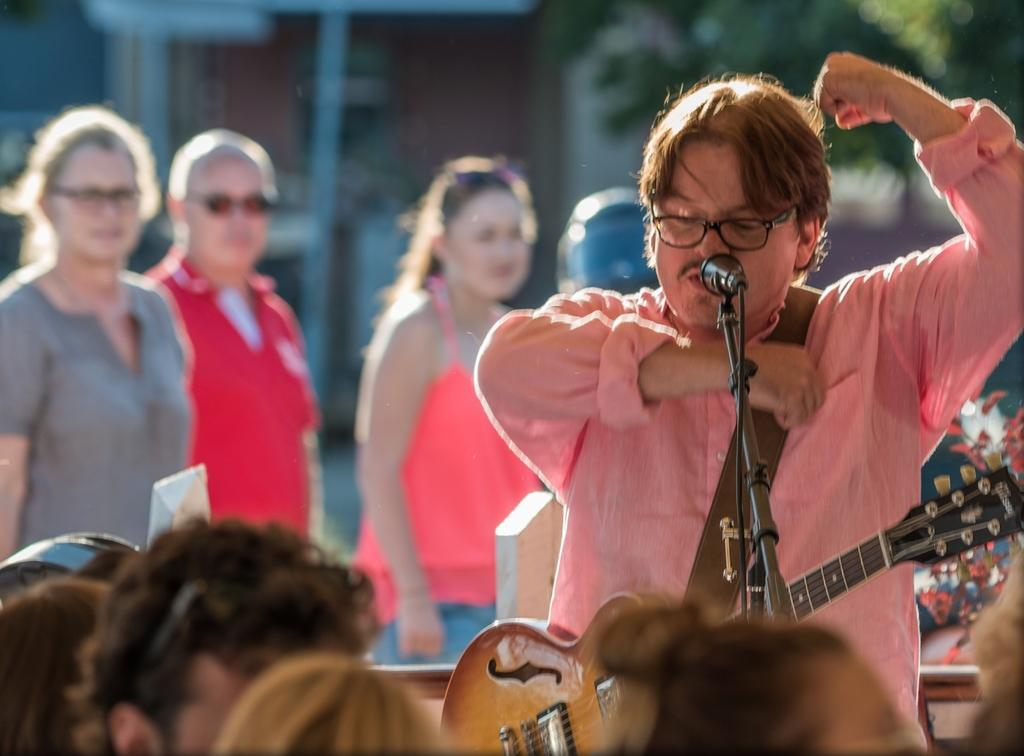What is happening in the image? There are people standing in the image. Can you describe the man in the image? The man is wearing a guitar in the image. What object is present that is typically used for amplifying sound? There is a microphone in the image. What type of cream can be seen on the earth in the image? There is no earth or cream present in the image. What key is the man using to play the guitar in the image? The image does not show the man playing the guitar, so it is not possible to determine which key he might be using. 